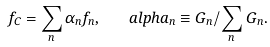Convert formula to latex. <formula><loc_0><loc_0><loc_500><loc_500>f _ { C } = \sum _ { n } \alpha _ { n } f _ { n } , \quad a l p h a _ { n } \equiv G _ { n } / \sum _ { n } G _ { n } .</formula> 